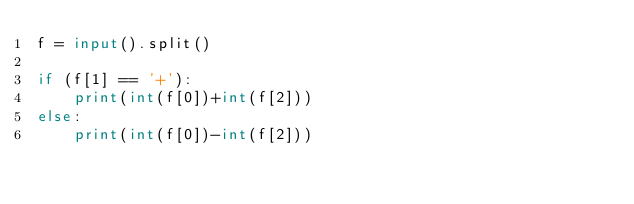<code> <loc_0><loc_0><loc_500><loc_500><_Python_>f = input().split()

if (f[1] == '+'):
    print(int(f[0])+int(f[2]))
else:
    print(int(f[0])-int(f[2]))</code> 